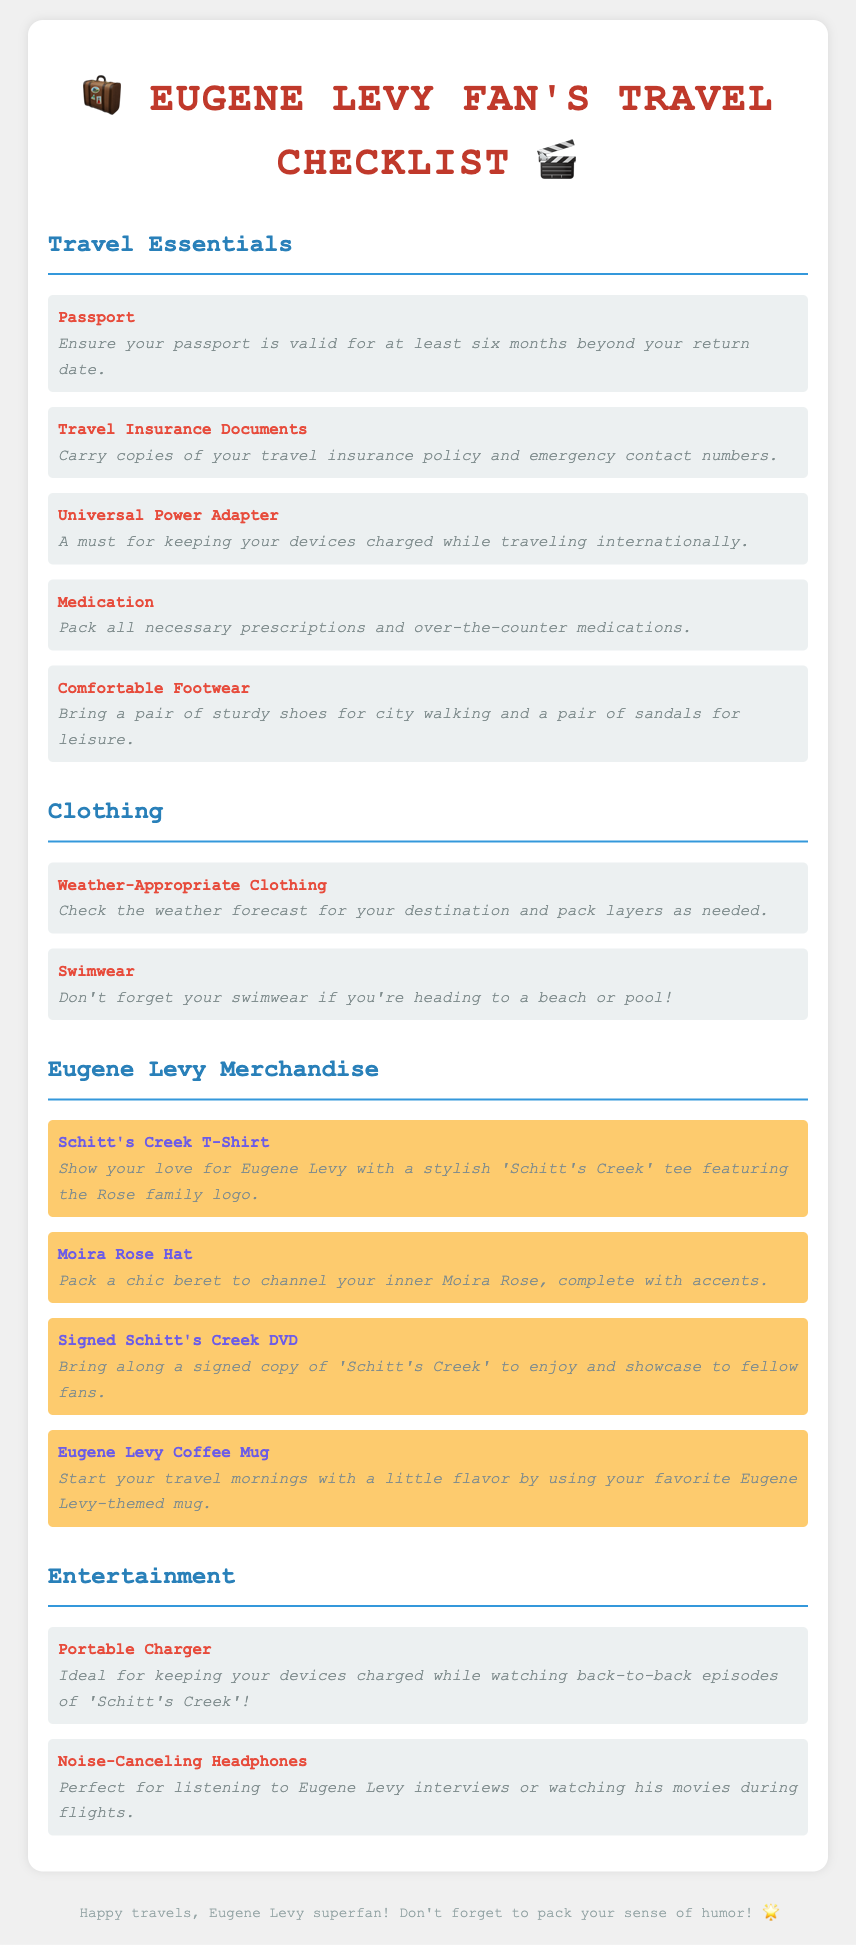What is the title of the document? The title of the document is prominently displayed and indicates it is a travel checklist for a Eugene Levy fan.
Answer: Eugene Levy Fan's Travel Checklist How many items are listed under Travel Essentials? The document lists five items under the Travel Essentials section.
Answer: 5 What clothing item is mentioned for swimming? The document specifically mentions one type of clothing for swimming under the Clothing section.
Answer: Swimwear What is one of the Eugene Levy-themed merchandise items? The document includes several Eugene Levy-themed merchandise items, which are clearly categorized.
Answer: Schitt's Creek T-Shirt What type of headphones are suggested for entertainment? The document highlights a specific type of headphones ideal for entertainment-related activities during travel.
Answer: Noise-Canceling Headphones Why is a portable charger included in the checklist? The document provides a reasoning behind including a portable charger, relating it to watching specific content during travel.
Answer: Watching back-to-back episodes of 'Schitt's Creek' What color is associated with the Eugene Levy merchandise background in the document? The merchandise section has a distinct background color to differentiate it, which is indicated in the description.
Answer: fdcb6e (yellow) What should you ensure about your passport? The document provides a specific guideline regarding passport validity in the travel essentials section.
Answer: Valid for at least six months beyond return date 